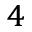Convert formula to latex. <formula><loc_0><loc_0><loc_500><loc_500>^ { 4 }</formula> 